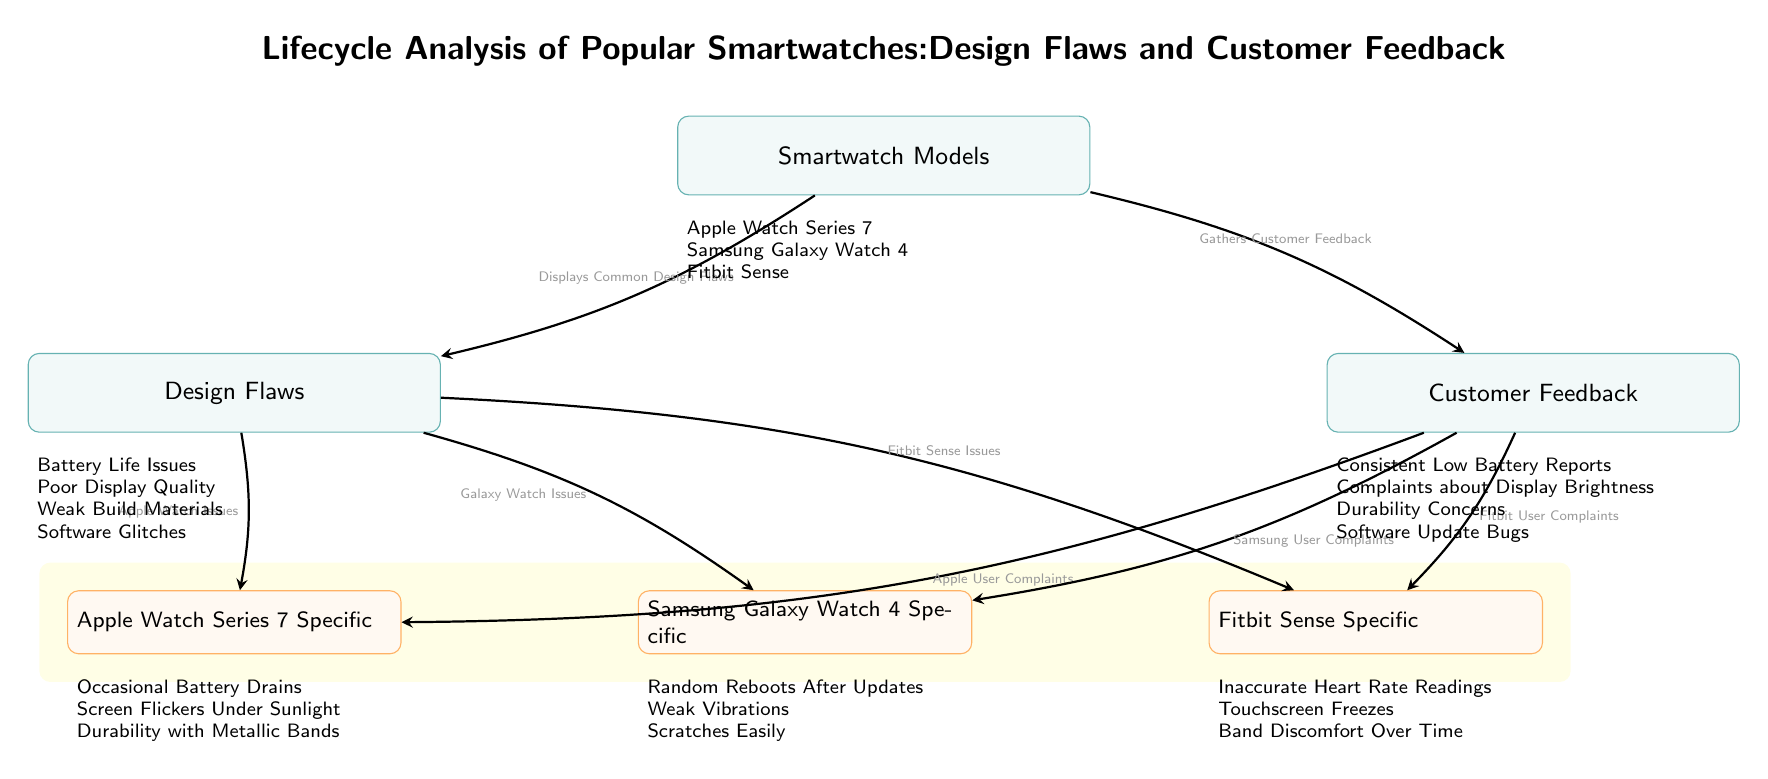What are the three smartwatch models presented in the diagram? The diagram lists three smartwatch models at the bottom of the main node. They are: Apple Watch Series 7, Samsung Galaxy Watch 4, and Fitbit Sense.
Answer: Apple Watch Series 7, Samsung Galaxy Watch 4, Fitbit Sense How many design flaws are mentioned in the diagram? The diagram outlines four design flaws under the main node "Design Flaws." These are Battery Life Issues, Poor Display Quality, Weak Build Materials, and Software Glitches.
Answer: Four Which smartwatch model has issues related to touchscreen freezes? The diagram states that the Fitbit Sense has a specific issue listed as "Touchscreen Freezes" under the detail node for Fitbit Sense.
Answer: Fitbit Sense What is a common issue shared between the Apple Watch Series 7 and Samsung Galaxy Watch 4? Both models have complaints related to battery performance, as indicated by the "Consistent Low Battery Reports" for Apple and "Occasional Battery Drains" for Apple Watch, but it's implied as a common concern together.
Answer: Battery Issues Which node directly connects customer feedback to the Samsung Galaxy Watch 4? The diagram shows an arrow from the "Customer Feedback" node pointing directly to the node representing the Samsung Galaxy Watch 4, labeled "Samsung User Complaints."
Answer: Samsung User Complaints How many specific design flaws are listed for the Samsung Galaxy Watch 4? Under the detail node for Samsung Galaxy Watch 4, three specific issues are indicated: Random Reboots After Updates, Weak Vibrations, and Scratches Easily.
Answer: Three What does the “Design Flaws” node lead to in terms of specific smartwatch issues? The "Design Flaws" node points to three specific nodes for the Apple Watch, Samsung Galaxy Watch, and Fitbit Sense, reflecting the issues for each model associated with design flaws.
Answer: Apple Watch Issues, Galaxy Watch Issues, Fitbit Sense Issues What type of feedback is mentioned for the Apple Watch Series 7? "Apple User Complaints" is stated under the Customer Feedback directed towards Apple Watch Series 7, indicating the type of feedback it received.
Answer: Apple User Complaints 